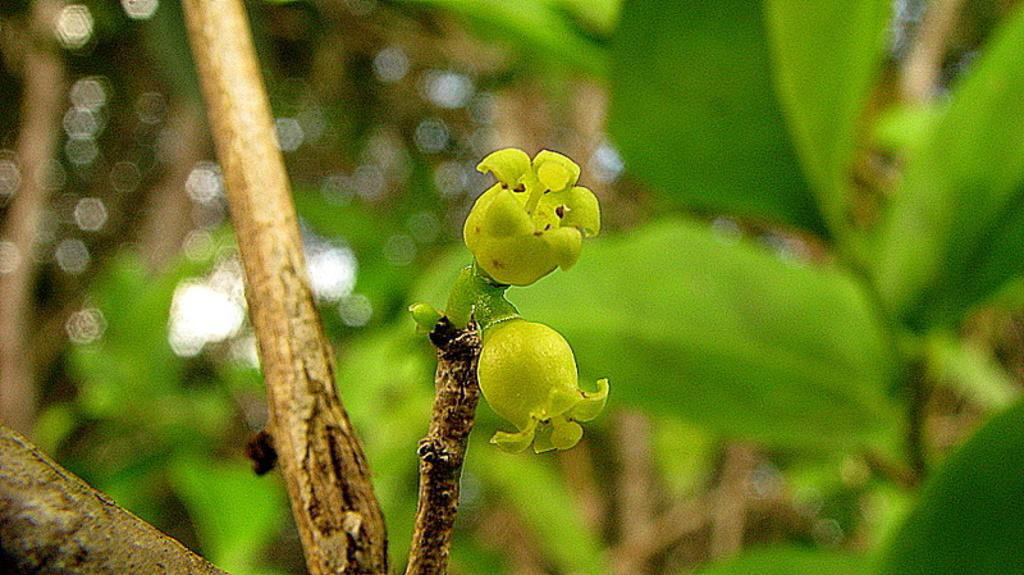What is the main subject of the image? The main subject of the image is a bud of a flower. Where is the stem of the plant located in the image? The stem of the plant is on the left side of the image. What color is the background of the image? The background of the image is green. What type of fruit can be heard making a sound in the image? There is no fruit present in the image, and therefore no sound can be heard. 